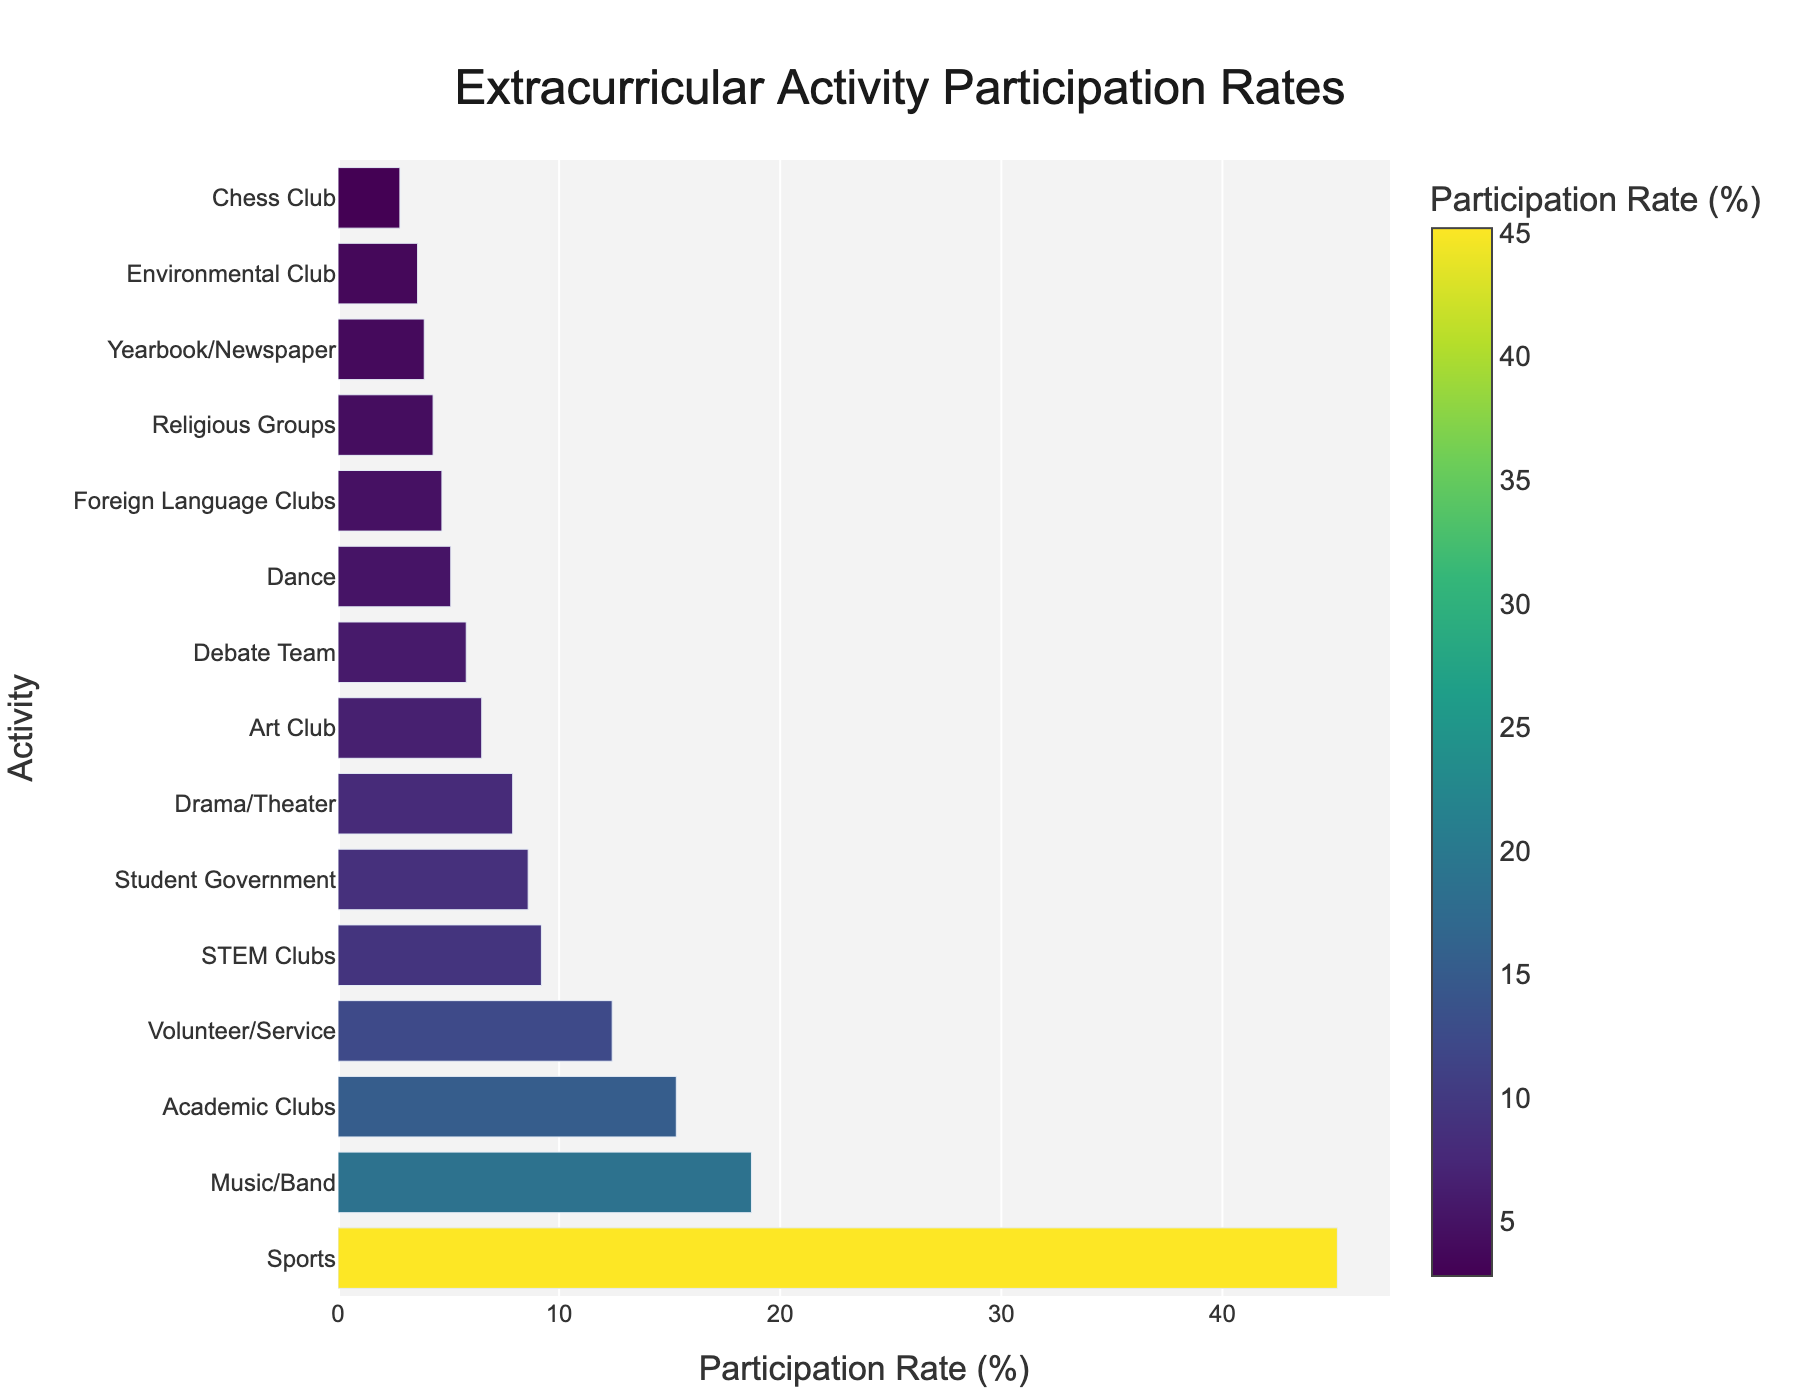Which extracurricular activity has the highest participation rate? The bar chart shows various extracurricular activities, and the activity with the longest bar represents the highest participation rate. Sports is the longest bar.
Answer: Sports Which extracurricular activity has the lowest participation rate? The bar chart shows various activities, and the activity with the shortest bar represents the lowest participation rate. Chess Club is the shortest bar.
Answer: Chess Club What is the difference in participation rates between Sports and Academic Clubs? The participation rate for Sports is 45.2% and for Academic Clubs is 15.3%. The difference is 45.2% - 15.3%.
Answer: 29.9% How many extracurricular activities have a participation rate higher than Volunteer/Service? Volunteer/Service has a participation rate of 12.4%. The activities with higher rates are Sports, Music/Band, and Academic Clubs, making it 3 activities.
Answer: 3 Which activity has a higher participation rate, Drama/Theater or Debate Team? The participation rate for Drama/Theater is 7.9% and for Debate Team is 5.8%. Drama/Theater has a higher participation rate.
Answer: Drama/Theater What is the average participation rate of Student Government, Drama/Theater, and Art Club? The participation rates are 8.6% for Student Government, 7.9% for Drama/Theater, and 6.5% for Art Club. Add them together and divide by 3. (8.6 + 7.9 + 6.5) / 3 = 23 / 3.
Answer: 7.67% Which two activities have the most similar participation rates? Compare the participation rates of all activities visually. Music/Band (18.7%) and Volunteer/Service (12.4%) have a relatively close difference of 6.3%, but STEM Clubs (9.2%) and Student Government (8.6%) have the smallest difference of 0.6%.
Answer: Student Government and STEM Clubs What is the cumulative participation rate for all activities except Sports? Add the participation rates for all activities excluding Sports: 18.7 + 15.3 + 8.6 + 7.9 + 6.5 + 5.8 + 12.4 + 4.7 + 9.2 + 3.9 + 5.1 + 2.8 + 3.6 + 4.3.
Answer: 108.8% Between Art Club and Foreign Language Clubs, which has the lower participation rate? The participation rate for Art Club is 6.5% and for Foreign Language Clubs is 4.7%. Foreign Language Clubs has the lower rate.
Answer: Foreign Language Clubs 